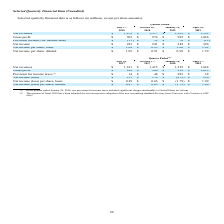According to Netapp's financial document, What did the provision for income taxes in the quarter ended January 26, 2018 include? significant charges attributable to United States tax reform.. The document states: "26, 2018, our provision for income taxes included significant charges attributable to United States tax reform. (2) The quarters of fiscal 2018 have b..." Also, How have the quarters of fiscal 2018 been adjusted? Based on the financial document, the answer is for our retrospective adoption of the new accounting standard Revenue from Contracts with Customers (ASC 606).. Also, What was the net revenue for the quarter of July 28, 2017? According to the financial document, 1,321 (in millions). The relevant text states: "Net revenues $ 1,321 $ 1,415 $ 1,539 $ 1,644..." Also, can you calculate: What was the change in the gross profit between the quarters of January 26 and April 27, 2018? Based on the calculation: 1,029-956, the result is 73 (in millions). This is based on the information: "Gross profit $ 824 $ 900 $ 956 $ 1,029 Gross profit $ 824 $ 900 $ 956 $ 1,029..." The key data points involved are: 1,029, 956. Also, can you calculate: What was the sum of the net revenues from the last two quarters? Based on the calculation: 1,539+1,644, the result is 3183 (in millions). This is based on the information: "Net revenues $ 1,321 $ 1,415 $ 1,539 $ 1,644 Net revenues $ 1,321 $ 1,415 $ 1,539 $ 1,644..." The key data points involved are: 1,539, 1,644. Also, can you calculate: What was the percentage change in Net income (loss) between July 28, 2017 and October 27, 2017? To answer this question, I need to perform calculations using the financial data. The calculation is: (174-131)/131, which equals 32.82 (percentage). This is based on the information: "Net income (loss) $ 131 $ 174 $ (479 ) $ 290 Net income (loss) $ 131 $ 174 $ (479 ) $ 290..." The key data points involved are: 131, 174. 